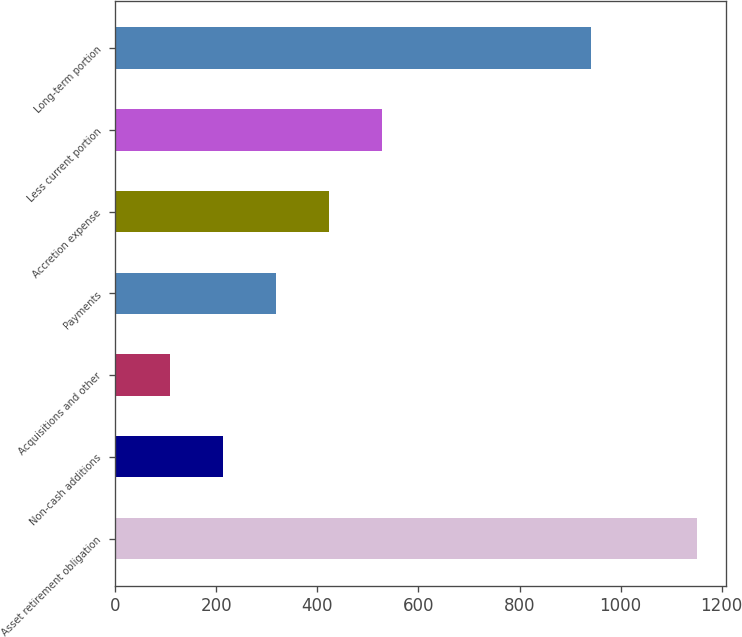<chart> <loc_0><loc_0><loc_500><loc_500><bar_chart><fcel>Asset retirement obligation<fcel>Non-cash additions<fcel>Acquisitions and other<fcel>Payments<fcel>Accretion expense<fcel>Less current portion<fcel>Long-term portion<nl><fcel>1151.56<fcel>214.16<fcel>109.38<fcel>318.94<fcel>423.72<fcel>528.5<fcel>942<nl></chart> 